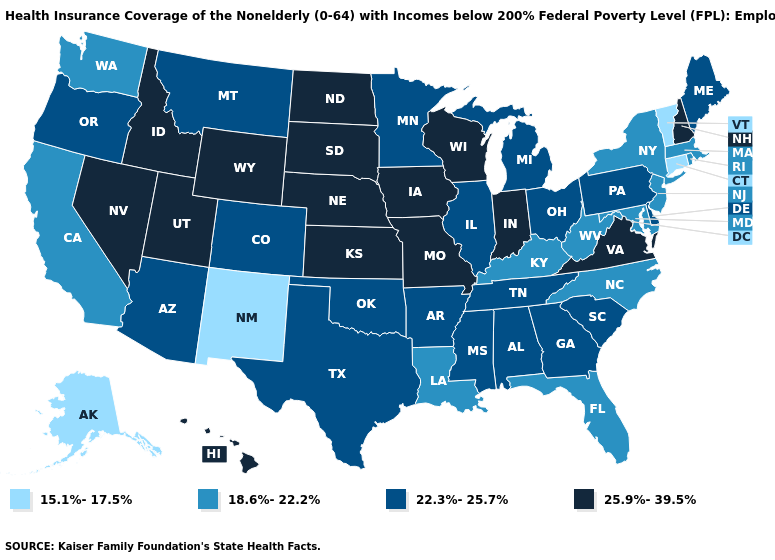Among the states that border North Carolina , which have the lowest value?
Concise answer only. Georgia, South Carolina, Tennessee. What is the value of Connecticut?
Write a very short answer. 15.1%-17.5%. Does the first symbol in the legend represent the smallest category?
Give a very brief answer. Yes. Name the states that have a value in the range 25.9%-39.5%?
Give a very brief answer. Hawaii, Idaho, Indiana, Iowa, Kansas, Missouri, Nebraska, Nevada, New Hampshire, North Dakota, South Dakota, Utah, Virginia, Wisconsin, Wyoming. Among the states that border California , which have the highest value?
Write a very short answer. Nevada. Does Missouri have a higher value than Georgia?
Short answer required. Yes. What is the value of New York?
Be succinct. 18.6%-22.2%. What is the highest value in the USA?
Concise answer only. 25.9%-39.5%. Name the states that have a value in the range 22.3%-25.7%?
Give a very brief answer. Alabama, Arizona, Arkansas, Colorado, Delaware, Georgia, Illinois, Maine, Michigan, Minnesota, Mississippi, Montana, Ohio, Oklahoma, Oregon, Pennsylvania, South Carolina, Tennessee, Texas. Does Delaware have the highest value in the USA?
Give a very brief answer. No. Does Delaware have the same value as Wyoming?
Keep it brief. No. Name the states that have a value in the range 25.9%-39.5%?
Keep it brief. Hawaii, Idaho, Indiana, Iowa, Kansas, Missouri, Nebraska, Nevada, New Hampshire, North Dakota, South Dakota, Utah, Virginia, Wisconsin, Wyoming. Does the first symbol in the legend represent the smallest category?
Be succinct. Yes. Which states have the lowest value in the USA?
Give a very brief answer. Alaska, Connecticut, New Mexico, Vermont. What is the value of Hawaii?
Answer briefly. 25.9%-39.5%. 